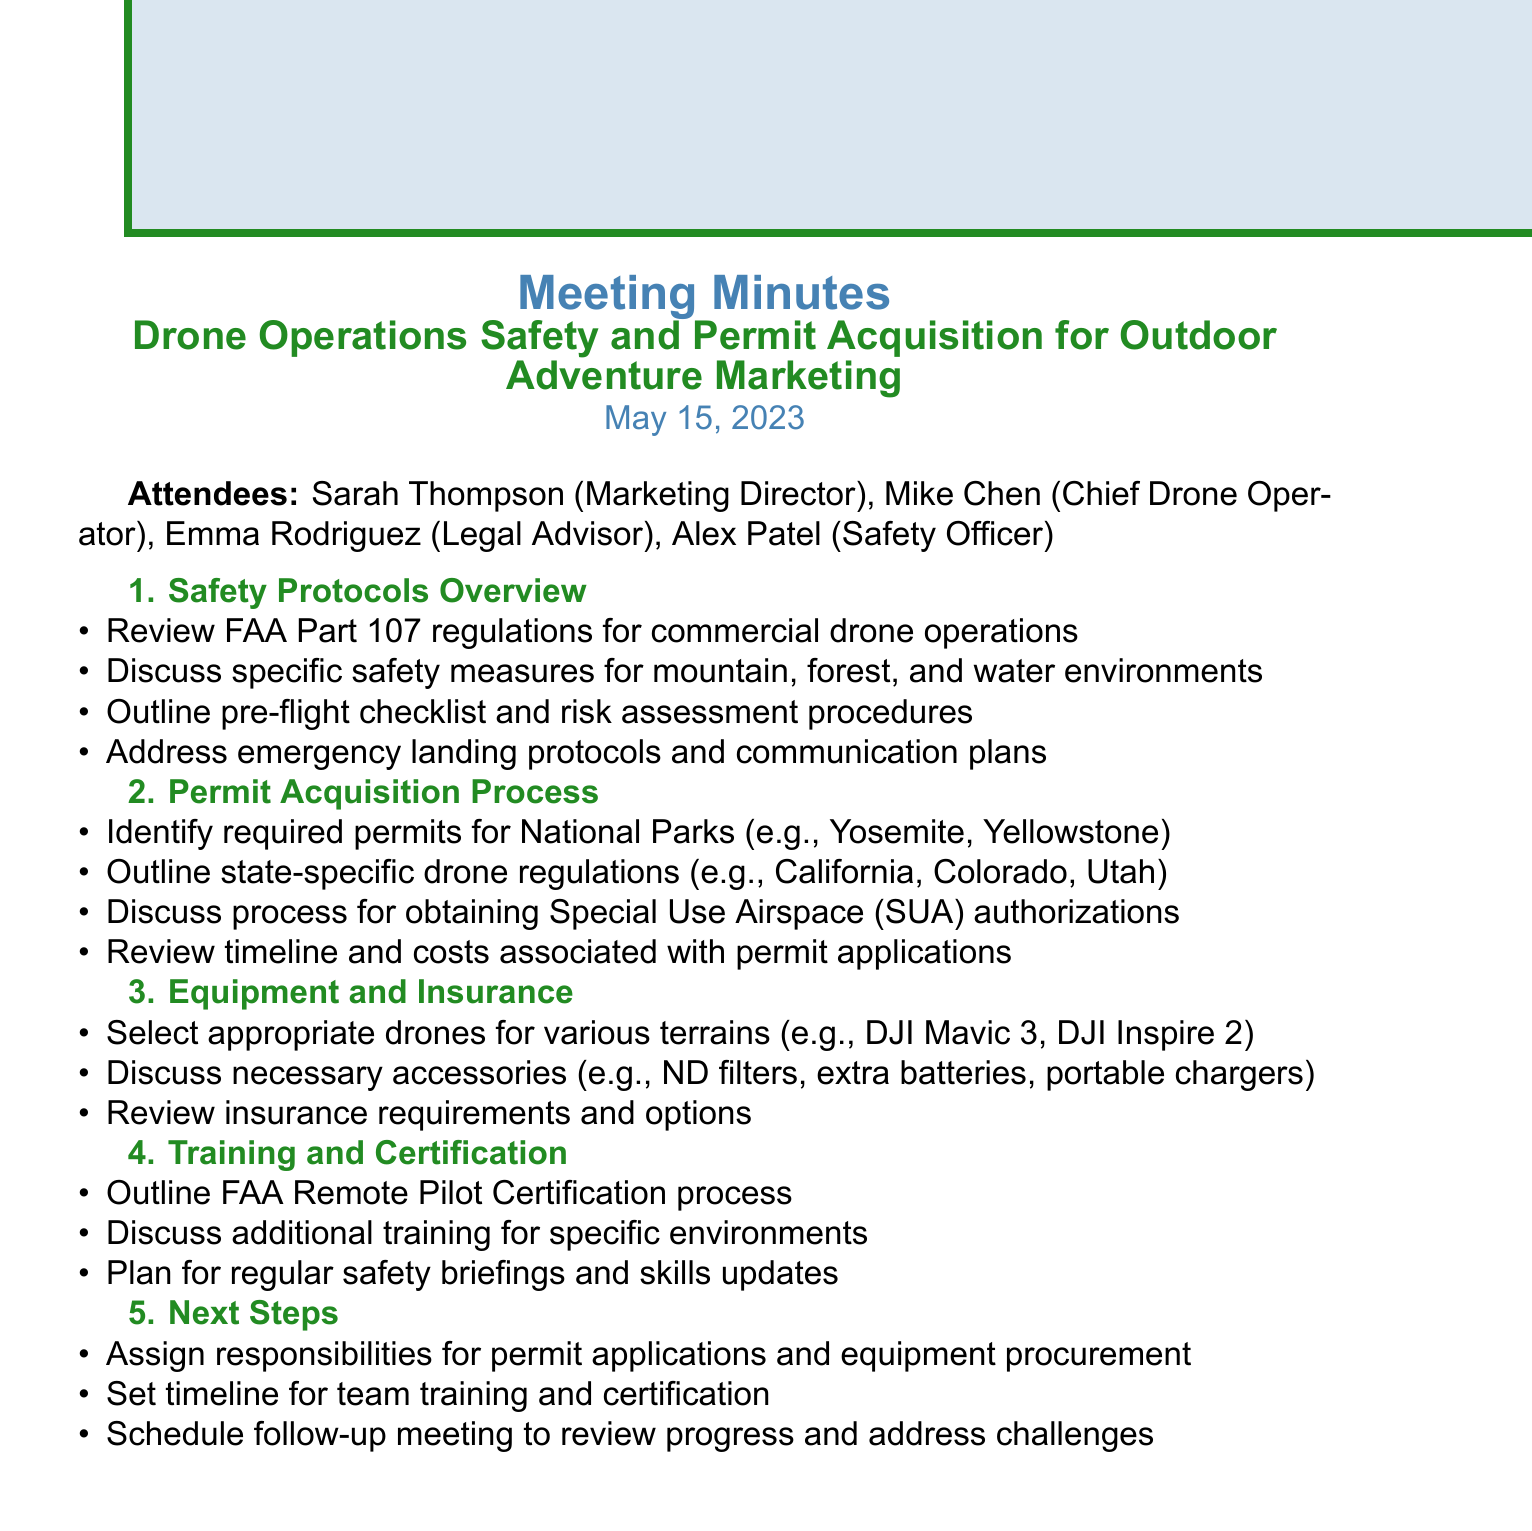What is the meeting date? The meeting date is explicitly stated in the document as May 15, 2023.
Answer: May 15, 2023 Who is the Chief Drone Operator? The document lists Mike Chen as the Chief Drone Operator among the attendees.
Answer: Mike Chen What regulations were reviewed in the Safety Protocols Overview? The document mentions the review of FAA Part 107 regulations for commercial drone operations as part of the safety overview.
Answer: FAA Part 107 Which permits were discussed for National Parks? The document references required permits for National Parks, specifically naming Yosemite and Yellowstone as examples.
Answer: Yosemite, Yellowstone What type of drone is suggested for versatility? The document mentions the DJI Mavic 3 as an appropriate drone for various terrains for its versatility.
Answer: DJI Mavic 3 What are the next steps outlined in the meeting? The document states that assigning responsibilities for permit applications and equipment procurement is part of the next steps.
Answer: Assign responsibilities How often should safety briefings occur? The document indicates the plan for regular safety briefings and skills updates, implying a consistent schedule.
Answer: Regularly What process was outlined regarding pilot certification? The document discusses the FAA Remote Pilot Certification process as part of the training and certification agenda item.
Answer: FAA Remote Pilot Certification Which environments were discussed for specific safety measures? The document highlights three environments: mountain, forest, and water, where specific safety measures were discussed.
Answer: Mountain, forest, water 